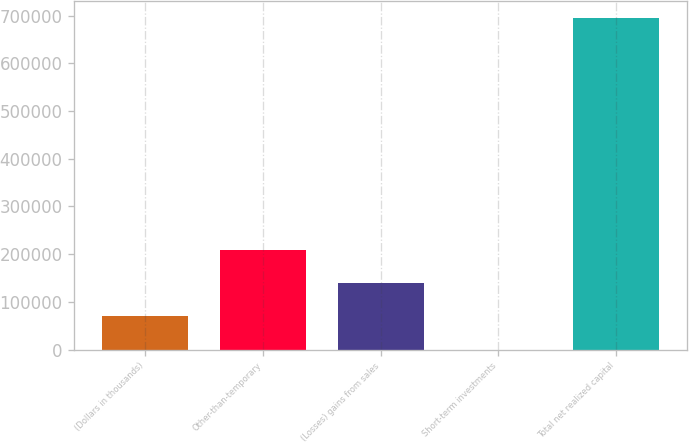<chart> <loc_0><loc_0><loc_500><loc_500><bar_chart><fcel>(Dollars in thousands)<fcel>Other-than-temporary<fcel>(Losses) gains from sales<fcel>Short-term investments<fcel>Total net realized capital<nl><fcel>69700.9<fcel>208841<fcel>139271<fcel>131<fcel>695830<nl></chart> 